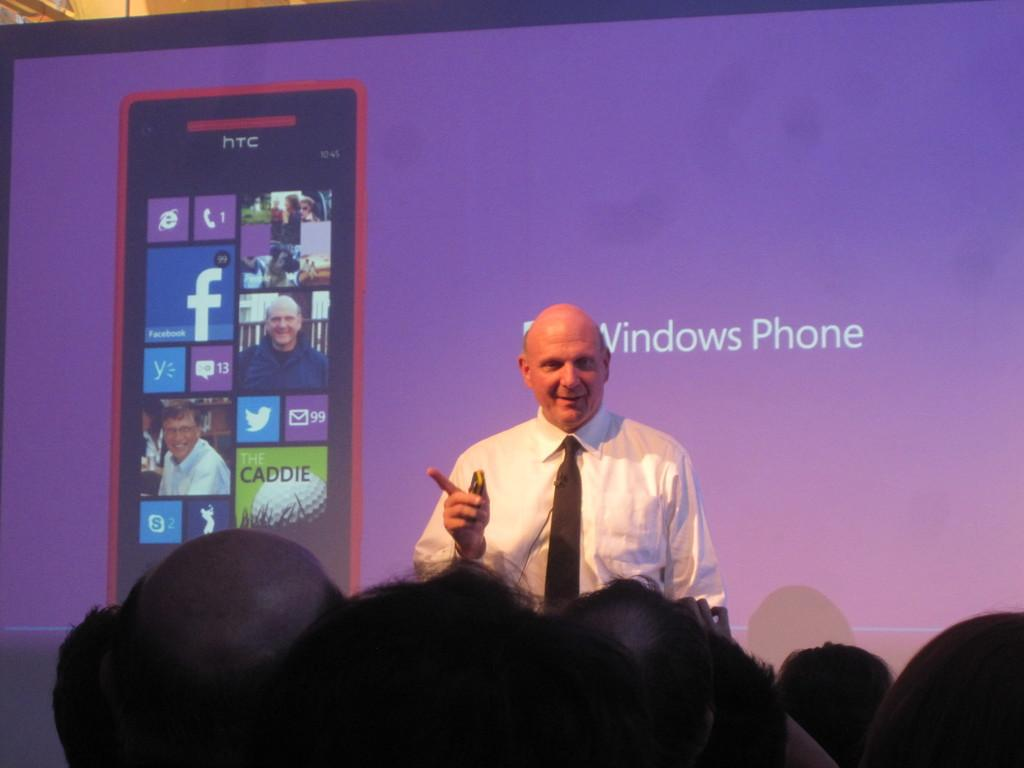<image>
Create a compact narrative representing the image presented. A man is giving a speech in front of a sign advertising Windows Phone. 